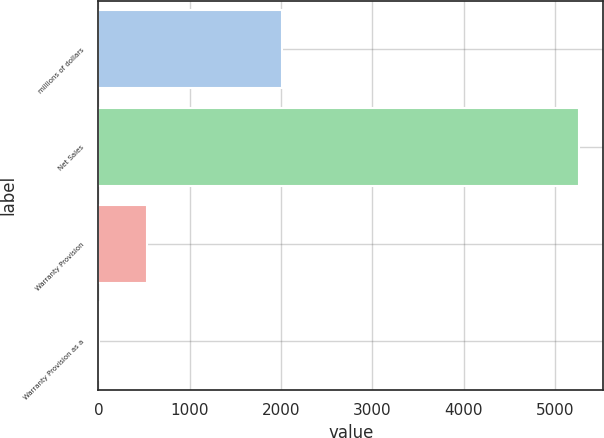Convert chart to OTSL. <chart><loc_0><loc_0><loc_500><loc_500><bar_chart><fcel>millions of dollars<fcel>Net Sales<fcel>Warranty Provision<fcel>Warranty Provision as a<nl><fcel>2008<fcel>5263.9<fcel>527.56<fcel>1.3<nl></chart> 